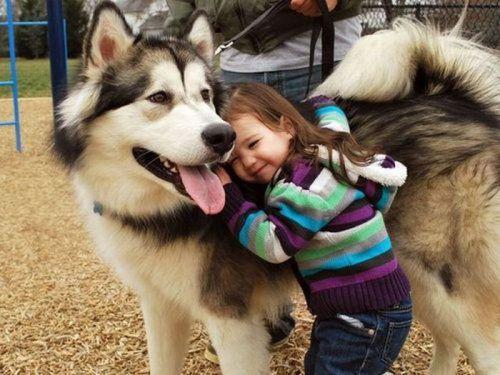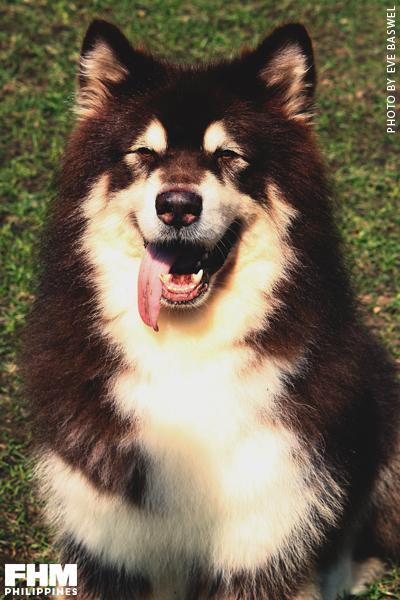The first image is the image on the left, the second image is the image on the right. Considering the images on both sides, is "The right image contains one human interacting with at least one dog." valid? Answer yes or no. No. The first image is the image on the left, the second image is the image on the right. For the images displayed, is the sentence "The combined images include at least two husky dogs, with at least one black-and-white, and one standing with tongue out and a man kneeling behind it." factually correct? Answer yes or no. No. 